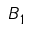Convert formula to latex. <formula><loc_0><loc_0><loc_500><loc_500>B _ { 1 }</formula> 